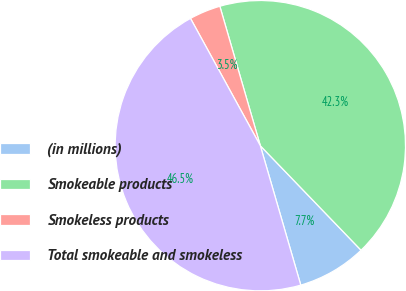Convert chart to OTSL. <chart><loc_0><loc_0><loc_500><loc_500><pie_chart><fcel>(in millions)<fcel>Smokeable products<fcel>Smokeless products<fcel>Total smokeable and smokeless<nl><fcel>7.71%<fcel>42.29%<fcel>3.49%<fcel>46.51%<nl></chart> 